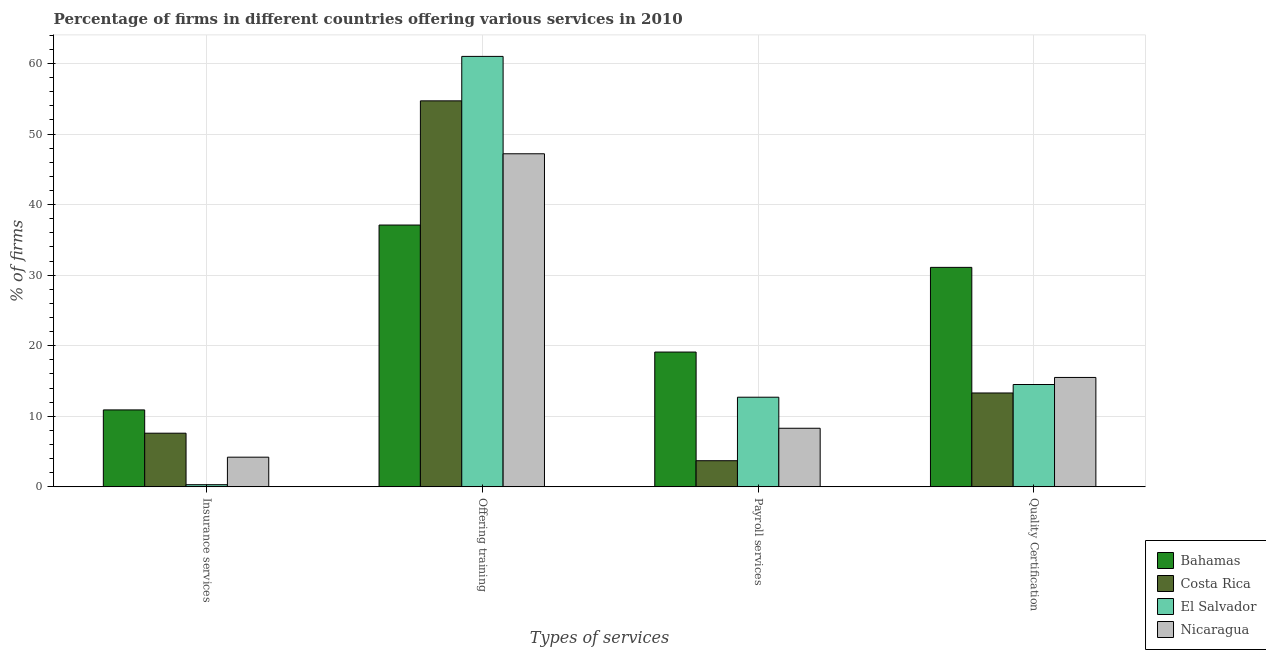Are the number of bars on each tick of the X-axis equal?
Offer a very short reply. Yes. How many bars are there on the 2nd tick from the right?
Provide a succinct answer. 4. What is the label of the 1st group of bars from the left?
Your answer should be compact. Insurance services. What is the percentage of firms offering insurance services in Costa Rica?
Give a very brief answer. 7.6. Across all countries, what is the maximum percentage of firms offering quality certification?
Provide a short and direct response. 31.1. Across all countries, what is the minimum percentage of firms offering training?
Ensure brevity in your answer.  37.1. In which country was the percentage of firms offering training maximum?
Offer a terse response. El Salvador. In which country was the percentage of firms offering insurance services minimum?
Make the answer very short. El Salvador. What is the total percentage of firms offering training in the graph?
Keep it short and to the point. 200. What is the difference between the percentage of firms offering payroll services in Nicaragua and that in El Salvador?
Ensure brevity in your answer.  -4.4. What is the average percentage of firms offering insurance services per country?
Provide a succinct answer. 5.75. What is the difference between the percentage of firms offering quality certification and percentage of firms offering payroll services in Nicaragua?
Offer a very short reply. 7.2. What is the ratio of the percentage of firms offering insurance services in El Salvador to that in Bahamas?
Give a very brief answer. 0.03. Is the difference between the percentage of firms offering quality certification in El Salvador and Nicaragua greater than the difference between the percentage of firms offering training in El Salvador and Nicaragua?
Ensure brevity in your answer.  No. What is the difference between the highest and the second highest percentage of firms offering quality certification?
Keep it short and to the point. 15.6. What is the difference between the highest and the lowest percentage of firms offering insurance services?
Offer a terse response. 10.6. In how many countries, is the percentage of firms offering training greater than the average percentage of firms offering training taken over all countries?
Offer a terse response. 2. Is the sum of the percentage of firms offering insurance services in Bahamas and Nicaragua greater than the maximum percentage of firms offering training across all countries?
Keep it short and to the point. No. What does the 1st bar from the left in Offering training represents?
Make the answer very short. Bahamas. What does the 2nd bar from the right in Offering training represents?
Offer a terse response. El Salvador. How many bars are there?
Offer a very short reply. 16. How many countries are there in the graph?
Make the answer very short. 4. What is the difference between two consecutive major ticks on the Y-axis?
Provide a short and direct response. 10. Where does the legend appear in the graph?
Offer a terse response. Bottom right. How are the legend labels stacked?
Provide a short and direct response. Vertical. What is the title of the graph?
Ensure brevity in your answer.  Percentage of firms in different countries offering various services in 2010. Does "El Salvador" appear as one of the legend labels in the graph?
Make the answer very short. Yes. What is the label or title of the X-axis?
Offer a very short reply. Types of services. What is the label or title of the Y-axis?
Make the answer very short. % of firms. What is the % of firms of Bahamas in Insurance services?
Give a very brief answer. 10.9. What is the % of firms in Costa Rica in Insurance services?
Offer a very short reply. 7.6. What is the % of firms in El Salvador in Insurance services?
Offer a terse response. 0.3. What is the % of firms in Bahamas in Offering training?
Offer a terse response. 37.1. What is the % of firms of Costa Rica in Offering training?
Ensure brevity in your answer.  54.7. What is the % of firms of Nicaragua in Offering training?
Your answer should be compact. 47.2. What is the % of firms of Bahamas in Payroll services?
Give a very brief answer. 19.1. What is the % of firms of Bahamas in Quality Certification?
Ensure brevity in your answer.  31.1. What is the % of firms of Costa Rica in Quality Certification?
Offer a very short reply. 13.3. What is the % of firms of El Salvador in Quality Certification?
Ensure brevity in your answer.  14.5. Across all Types of services, what is the maximum % of firms in Bahamas?
Your answer should be very brief. 37.1. Across all Types of services, what is the maximum % of firms of Costa Rica?
Your answer should be very brief. 54.7. Across all Types of services, what is the maximum % of firms in El Salvador?
Provide a succinct answer. 61. Across all Types of services, what is the maximum % of firms of Nicaragua?
Your answer should be very brief. 47.2. Across all Types of services, what is the minimum % of firms of Bahamas?
Your response must be concise. 10.9. Across all Types of services, what is the minimum % of firms of Costa Rica?
Keep it short and to the point. 3.7. Across all Types of services, what is the minimum % of firms of El Salvador?
Offer a very short reply. 0.3. Across all Types of services, what is the minimum % of firms of Nicaragua?
Your answer should be compact. 4.2. What is the total % of firms in Bahamas in the graph?
Give a very brief answer. 98.2. What is the total % of firms of Costa Rica in the graph?
Your answer should be compact. 79.3. What is the total % of firms of El Salvador in the graph?
Your response must be concise. 88.5. What is the total % of firms of Nicaragua in the graph?
Your answer should be compact. 75.2. What is the difference between the % of firms in Bahamas in Insurance services and that in Offering training?
Your answer should be very brief. -26.2. What is the difference between the % of firms of Costa Rica in Insurance services and that in Offering training?
Make the answer very short. -47.1. What is the difference between the % of firms in El Salvador in Insurance services and that in Offering training?
Your response must be concise. -60.7. What is the difference between the % of firms of Nicaragua in Insurance services and that in Offering training?
Offer a very short reply. -43. What is the difference between the % of firms of Costa Rica in Insurance services and that in Payroll services?
Provide a succinct answer. 3.9. What is the difference between the % of firms of El Salvador in Insurance services and that in Payroll services?
Provide a succinct answer. -12.4. What is the difference between the % of firms of Bahamas in Insurance services and that in Quality Certification?
Your answer should be very brief. -20.2. What is the difference between the % of firms of Costa Rica in Insurance services and that in Quality Certification?
Keep it short and to the point. -5.7. What is the difference between the % of firms of El Salvador in Offering training and that in Payroll services?
Your response must be concise. 48.3. What is the difference between the % of firms in Nicaragua in Offering training and that in Payroll services?
Provide a succinct answer. 38.9. What is the difference between the % of firms in Bahamas in Offering training and that in Quality Certification?
Your answer should be very brief. 6. What is the difference between the % of firms in Costa Rica in Offering training and that in Quality Certification?
Your response must be concise. 41.4. What is the difference between the % of firms of El Salvador in Offering training and that in Quality Certification?
Provide a succinct answer. 46.5. What is the difference between the % of firms in Nicaragua in Offering training and that in Quality Certification?
Give a very brief answer. 31.7. What is the difference between the % of firms of Costa Rica in Payroll services and that in Quality Certification?
Make the answer very short. -9.6. What is the difference between the % of firms of El Salvador in Payroll services and that in Quality Certification?
Your answer should be very brief. -1.8. What is the difference between the % of firms of Nicaragua in Payroll services and that in Quality Certification?
Offer a terse response. -7.2. What is the difference between the % of firms in Bahamas in Insurance services and the % of firms in Costa Rica in Offering training?
Your answer should be compact. -43.8. What is the difference between the % of firms in Bahamas in Insurance services and the % of firms in El Salvador in Offering training?
Your answer should be compact. -50.1. What is the difference between the % of firms of Bahamas in Insurance services and the % of firms of Nicaragua in Offering training?
Ensure brevity in your answer.  -36.3. What is the difference between the % of firms in Costa Rica in Insurance services and the % of firms in El Salvador in Offering training?
Your answer should be compact. -53.4. What is the difference between the % of firms of Costa Rica in Insurance services and the % of firms of Nicaragua in Offering training?
Offer a very short reply. -39.6. What is the difference between the % of firms of El Salvador in Insurance services and the % of firms of Nicaragua in Offering training?
Provide a succinct answer. -46.9. What is the difference between the % of firms in Bahamas in Insurance services and the % of firms in Costa Rica in Payroll services?
Keep it short and to the point. 7.2. What is the difference between the % of firms of Bahamas in Insurance services and the % of firms of Nicaragua in Payroll services?
Your answer should be compact. 2.6. What is the difference between the % of firms of El Salvador in Insurance services and the % of firms of Nicaragua in Payroll services?
Make the answer very short. -8. What is the difference between the % of firms in Bahamas in Insurance services and the % of firms in El Salvador in Quality Certification?
Make the answer very short. -3.6. What is the difference between the % of firms of El Salvador in Insurance services and the % of firms of Nicaragua in Quality Certification?
Make the answer very short. -15.2. What is the difference between the % of firms of Bahamas in Offering training and the % of firms of Costa Rica in Payroll services?
Your answer should be compact. 33.4. What is the difference between the % of firms in Bahamas in Offering training and the % of firms in El Salvador in Payroll services?
Give a very brief answer. 24.4. What is the difference between the % of firms in Bahamas in Offering training and the % of firms in Nicaragua in Payroll services?
Your answer should be compact. 28.8. What is the difference between the % of firms in Costa Rica in Offering training and the % of firms in El Salvador in Payroll services?
Offer a very short reply. 42. What is the difference between the % of firms of Costa Rica in Offering training and the % of firms of Nicaragua in Payroll services?
Provide a short and direct response. 46.4. What is the difference between the % of firms in El Salvador in Offering training and the % of firms in Nicaragua in Payroll services?
Offer a very short reply. 52.7. What is the difference between the % of firms of Bahamas in Offering training and the % of firms of Costa Rica in Quality Certification?
Your answer should be very brief. 23.8. What is the difference between the % of firms in Bahamas in Offering training and the % of firms in El Salvador in Quality Certification?
Make the answer very short. 22.6. What is the difference between the % of firms in Bahamas in Offering training and the % of firms in Nicaragua in Quality Certification?
Ensure brevity in your answer.  21.6. What is the difference between the % of firms of Costa Rica in Offering training and the % of firms of El Salvador in Quality Certification?
Keep it short and to the point. 40.2. What is the difference between the % of firms in Costa Rica in Offering training and the % of firms in Nicaragua in Quality Certification?
Your answer should be very brief. 39.2. What is the difference between the % of firms in El Salvador in Offering training and the % of firms in Nicaragua in Quality Certification?
Offer a terse response. 45.5. What is the difference between the % of firms in Bahamas in Payroll services and the % of firms in Costa Rica in Quality Certification?
Offer a terse response. 5.8. What is the difference between the % of firms of Bahamas in Payroll services and the % of firms of El Salvador in Quality Certification?
Ensure brevity in your answer.  4.6. What is the difference between the % of firms of Bahamas in Payroll services and the % of firms of Nicaragua in Quality Certification?
Give a very brief answer. 3.6. What is the difference between the % of firms in Costa Rica in Payroll services and the % of firms in El Salvador in Quality Certification?
Your response must be concise. -10.8. What is the difference between the % of firms in Costa Rica in Payroll services and the % of firms in Nicaragua in Quality Certification?
Offer a very short reply. -11.8. What is the difference between the % of firms of El Salvador in Payroll services and the % of firms of Nicaragua in Quality Certification?
Your answer should be very brief. -2.8. What is the average % of firms in Bahamas per Types of services?
Provide a short and direct response. 24.55. What is the average % of firms of Costa Rica per Types of services?
Ensure brevity in your answer.  19.82. What is the average % of firms in El Salvador per Types of services?
Give a very brief answer. 22.12. What is the average % of firms in Nicaragua per Types of services?
Your answer should be compact. 18.8. What is the difference between the % of firms in Bahamas and % of firms in Costa Rica in Insurance services?
Offer a terse response. 3.3. What is the difference between the % of firms of Costa Rica and % of firms of Nicaragua in Insurance services?
Give a very brief answer. 3.4. What is the difference between the % of firms in Bahamas and % of firms in Costa Rica in Offering training?
Provide a short and direct response. -17.6. What is the difference between the % of firms in Bahamas and % of firms in El Salvador in Offering training?
Keep it short and to the point. -23.9. What is the difference between the % of firms of Costa Rica and % of firms of El Salvador in Offering training?
Your response must be concise. -6.3. What is the difference between the % of firms in Costa Rica and % of firms in Nicaragua in Offering training?
Provide a succinct answer. 7.5. What is the difference between the % of firms in El Salvador and % of firms in Nicaragua in Offering training?
Offer a very short reply. 13.8. What is the difference between the % of firms in El Salvador and % of firms in Nicaragua in Payroll services?
Offer a terse response. 4.4. What is the difference between the % of firms in Bahamas and % of firms in Costa Rica in Quality Certification?
Your answer should be compact. 17.8. What is the difference between the % of firms of Bahamas and % of firms of Nicaragua in Quality Certification?
Your response must be concise. 15.6. What is the difference between the % of firms of Costa Rica and % of firms of El Salvador in Quality Certification?
Make the answer very short. -1.2. What is the difference between the % of firms of Costa Rica and % of firms of Nicaragua in Quality Certification?
Give a very brief answer. -2.2. What is the difference between the % of firms of El Salvador and % of firms of Nicaragua in Quality Certification?
Offer a very short reply. -1. What is the ratio of the % of firms in Bahamas in Insurance services to that in Offering training?
Your answer should be compact. 0.29. What is the ratio of the % of firms in Costa Rica in Insurance services to that in Offering training?
Provide a short and direct response. 0.14. What is the ratio of the % of firms in El Salvador in Insurance services to that in Offering training?
Your response must be concise. 0. What is the ratio of the % of firms in Nicaragua in Insurance services to that in Offering training?
Keep it short and to the point. 0.09. What is the ratio of the % of firms in Bahamas in Insurance services to that in Payroll services?
Your answer should be compact. 0.57. What is the ratio of the % of firms in Costa Rica in Insurance services to that in Payroll services?
Provide a short and direct response. 2.05. What is the ratio of the % of firms in El Salvador in Insurance services to that in Payroll services?
Offer a terse response. 0.02. What is the ratio of the % of firms in Nicaragua in Insurance services to that in Payroll services?
Ensure brevity in your answer.  0.51. What is the ratio of the % of firms in Bahamas in Insurance services to that in Quality Certification?
Your answer should be very brief. 0.35. What is the ratio of the % of firms of Costa Rica in Insurance services to that in Quality Certification?
Your answer should be very brief. 0.57. What is the ratio of the % of firms in El Salvador in Insurance services to that in Quality Certification?
Your response must be concise. 0.02. What is the ratio of the % of firms of Nicaragua in Insurance services to that in Quality Certification?
Your answer should be compact. 0.27. What is the ratio of the % of firms of Bahamas in Offering training to that in Payroll services?
Offer a terse response. 1.94. What is the ratio of the % of firms in Costa Rica in Offering training to that in Payroll services?
Offer a terse response. 14.78. What is the ratio of the % of firms in El Salvador in Offering training to that in Payroll services?
Ensure brevity in your answer.  4.8. What is the ratio of the % of firms of Nicaragua in Offering training to that in Payroll services?
Offer a terse response. 5.69. What is the ratio of the % of firms in Bahamas in Offering training to that in Quality Certification?
Your answer should be very brief. 1.19. What is the ratio of the % of firms in Costa Rica in Offering training to that in Quality Certification?
Your answer should be very brief. 4.11. What is the ratio of the % of firms of El Salvador in Offering training to that in Quality Certification?
Provide a short and direct response. 4.21. What is the ratio of the % of firms in Nicaragua in Offering training to that in Quality Certification?
Provide a succinct answer. 3.05. What is the ratio of the % of firms of Bahamas in Payroll services to that in Quality Certification?
Give a very brief answer. 0.61. What is the ratio of the % of firms in Costa Rica in Payroll services to that in Quality Certification?
Offer a very short reply. 0.28. What is the ratio of the % of firms in El Salvador in Payroll services to that in Quality Certification?
Offer a very short reply. 0.88. What is the ratio of the % of firms of Nicaragua in Payroll services to that in Quality Certification?
Keep it short and to the point. 0.54. What is the difference between the highest and the second highest % of firms of Bahamas?
Provide a succinct answer. 6. What is the difference between the highest and the second highest % of firms in Costa Rica?
Your answer should be compact. 41.4. What is the difference between the highest and the second highest % of firms in El Salvador?
Keep it short and to the point. 46.5. What is the difference between the highest and the second highest % of firms of Nicaragua?
Ensure brevity in your answer.  31.7. What is the difference between the highest and the lowest % of firms in Bahamas?
Make the answer very short. 26.2. What is the difference between the highest and the lowest % of firms in Costa Rica?
Provide a succinct answer. 51. What is the difference between the highest and the lowest % of firms of El Salvador?
Provide a short and direct response. 60.7. What is the difference between the highest and the lowest % of firms in Nicaragua?
Your answer should be compact. 43. 